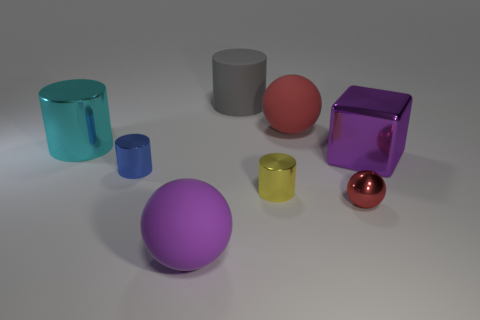There is another large object that is the same shape as the big red thing; what material is it?
Your response must be concise. Rubber. Is there any other thing that is the same color as the large cube?
Give a very brief answer. Yes. There is a rubber ball to the right of the gray object; is it the same color as the tiny ball?
Keep it short and to the point. Yes. What is the material of the big object that is to the right of the big gray thing and to the left of the tiny red metallic thing?
Offer a very short reply. Rubber. There is a cylinder that is behind the cyan shiny object; does it have the same size as the small yellow metal cylinder?
Your answer should be compact. No. The small yellow metal object has what shape?
Keep it short and to the point. Cylinder. How many purple things are the same shape as the small red shiny object?
Offer a very short reply. 1. How many spheres are both right of the yellow shiny cylinder and on the left side of the gray rubber object?
Provide a succinct answer. 0. The tiny ball is what color?
Provide a short and direct response. Red. Are there any gray cylinders that have the same material as the cyan thing?
Provide a short and direct response. No. 